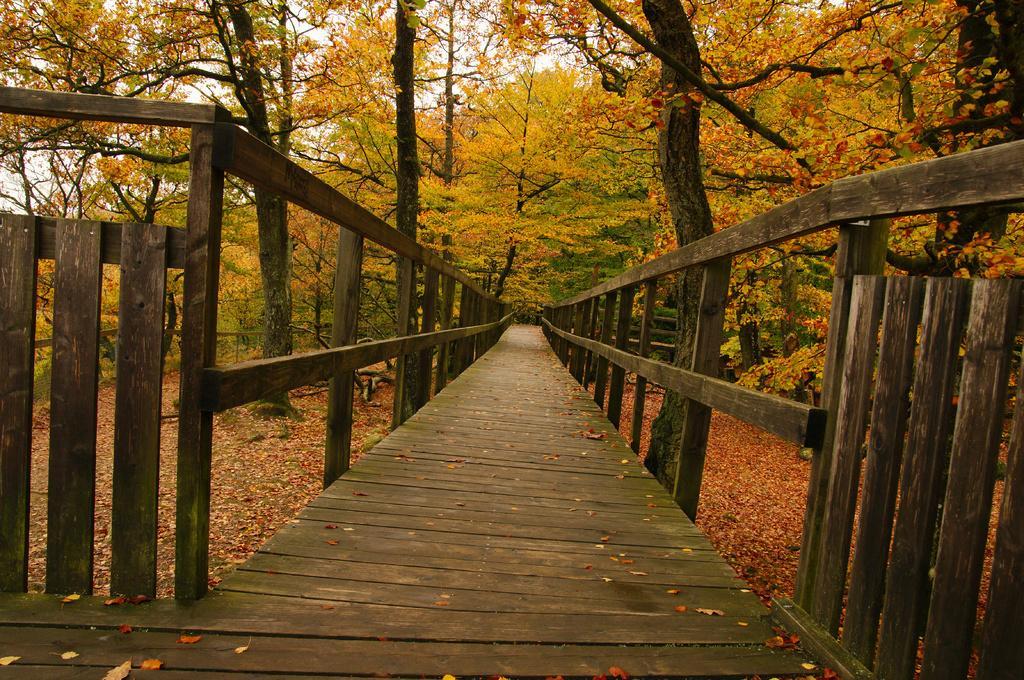Please provide a concise description of this image. In this image I can see a wooden fencing,wooden path and trees. I can see few yellow and orange leaves. The sky is in white color. 